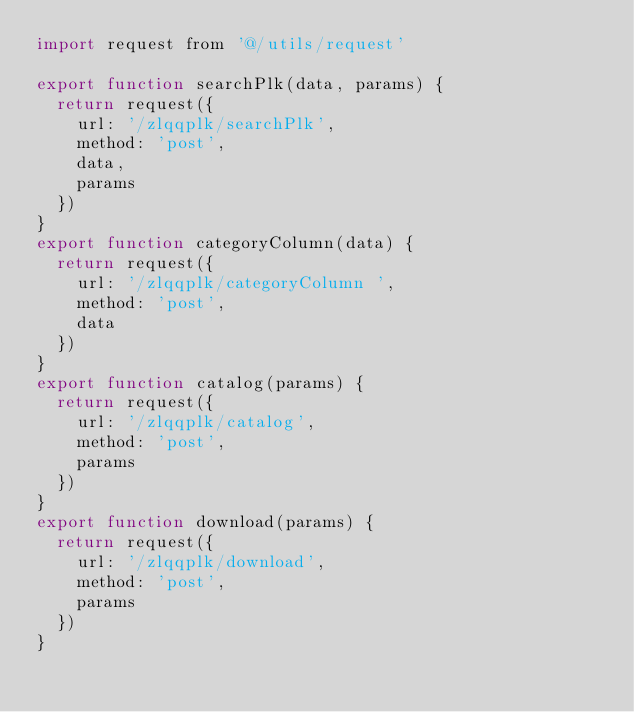Convert code to text. <code><loc_0><loc_0><loc_500><loc_500><_JavaScript_>import request from '@/utils/request'

export function searchPlk(data, params) {
  return request({
    url: '/zlqqplk/searchPlk',
    method: 'post',
    data,
    params
  })
}
export function categoryColumn(data) {
  return request({
    url: '/zlqqplk/categoryColumn ',
    method: 'post',
    data
  })
}
export function catalog(params) {
  return request({
    url: '/zlqqplk/catalog',
    method: 'post',
    params
  })
}
export function download(params) {
  return request({
    url: '/zlqqplk/download',
    method: 'post',
    params
  })
}

</code> 